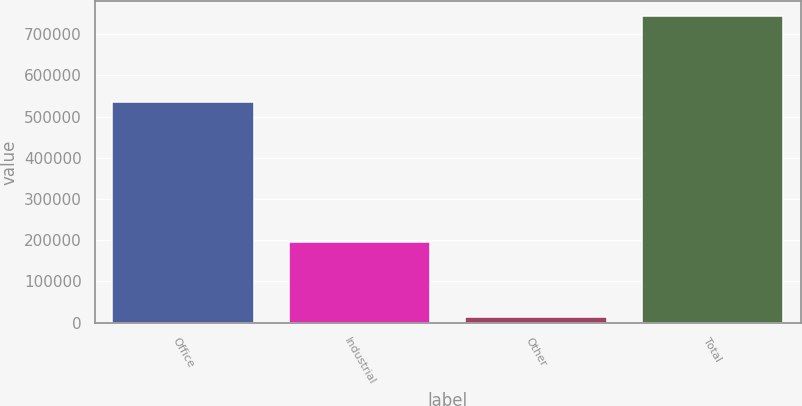<chart> <loc_0><loc_0><loc_500><loc_500><bar_chart><fcel>Office<fcel>Industrial<fcel>Other<fcel>Total<nl><fcel>534369<fcel>194670<fcel>14509<fcel>743548<nl></chart> 